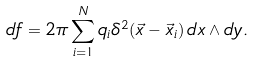Convert formula to latex. <formula><loc_0><loc_0><loc_500><loc_500>d f = 2 \pi \sum _ { i = 1 } ^ { N } q _ { i } \delta ^ { 2 } ( \vec { x } - \vec { x } _ { i } ) \, d x \wedge d y .</formula> 